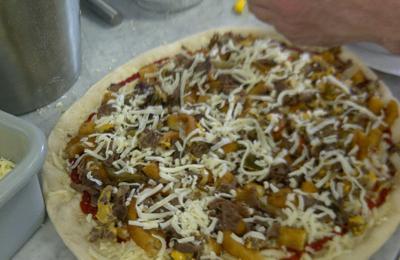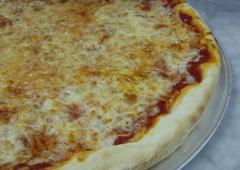The first image is the image on the left, the second image is the image on the right. Examine the images to the left and right. Is the description "The left and right image contains the same number of  uneaten pizzas." accurate? Answer yes or no. Yes. The first image is the image on the left, the second image is the image on the right. Analyze the images presented: Is the assertion "Each image contains one round pizza that is not in a box and does not have any slices missing." valid? Answer yes or no. Yes. 